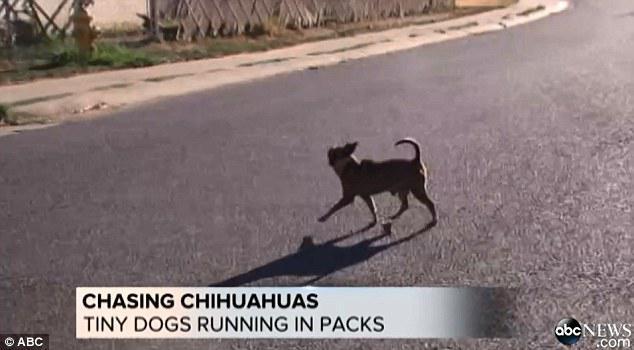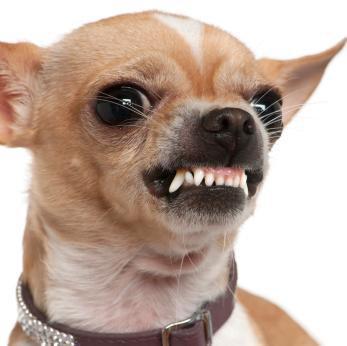The first image is the image on the left, the second image is the image on the right. For the images shown, is this caption "An image contains a chihuahua snarling and showing its teeth." true? Answer yes or no. Yes. 